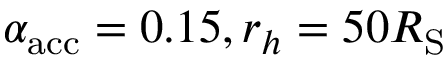Convert formula to latex. <formula><loc_0><loc_0><loc_500><loc_500>\alpha _ { a c c } = 0 . 1 5 , r _ { h } = 5 0 R _ { S }</formula> 